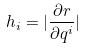<formula> <loc_0><loc_0><loc_500><loc_500>h _ { i } = | \frac { \partial r } { \partial q ^ { i } } |</formula> 